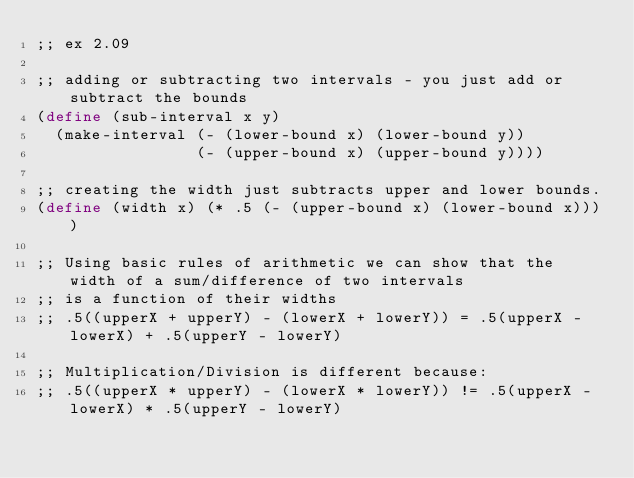Convert code to text. <code><loc_0><loc_0><loc_500><loc_500><_Scheme_>;; ex 2.09

;; adding or subtracting two intervals - you just add or subtract the bounds
(define (sub-interval x y)
  (make-interval (- (lower-bound x) (lower-bound y))
                 (- (upper-bound x) (upper-bound y))))

;; creating the width just subtracts upper and lower bounds.
(define (width x) (* .5 (- (upper-bound x) (lower-bound x))))

;; Using basic rules of arithmetic we can show that the width of a sum/difference of two intervals
;; is a function of their widths
;; .5((upperX + upperY) - (lowerX + lowerY)) = .5(upperX - lowerX) + .5(upperY - lowerY)

;; Multiplication/Division is different because:
;; .5((upperX * upperY) - (lowerX * lowerY)) != .5(upperX - lowerX) * .5(upperY - lowerY)
</code> 